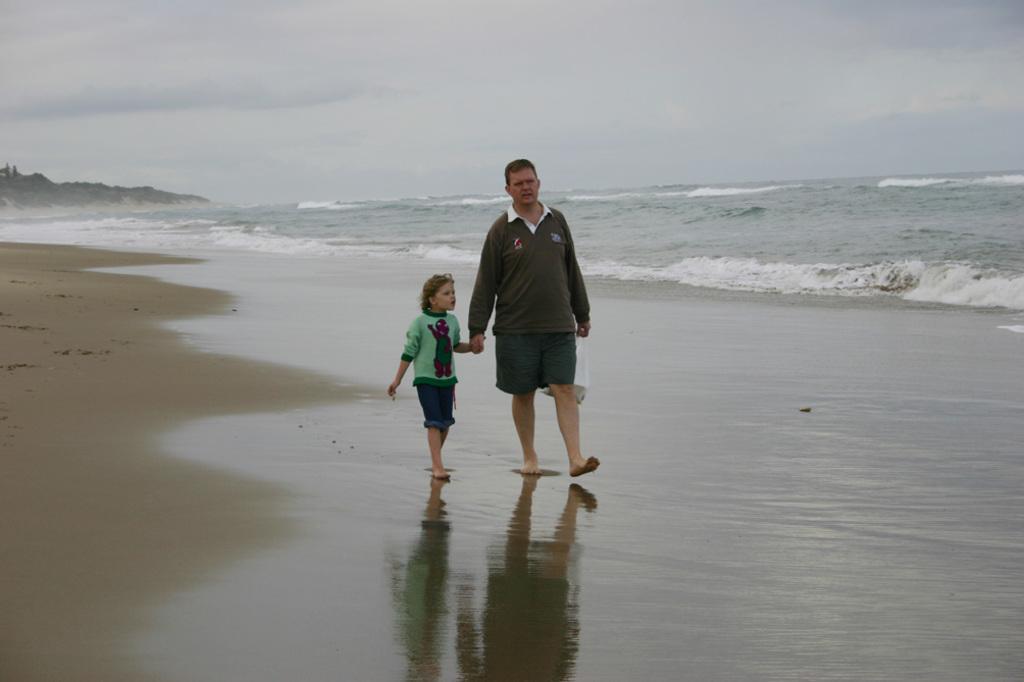In one or two sentences, can you explain what this image depicts? In the image there is a man and a kid walking on the side of the beach and on the left side background it seems to be a hill and above its sky with clouds. 